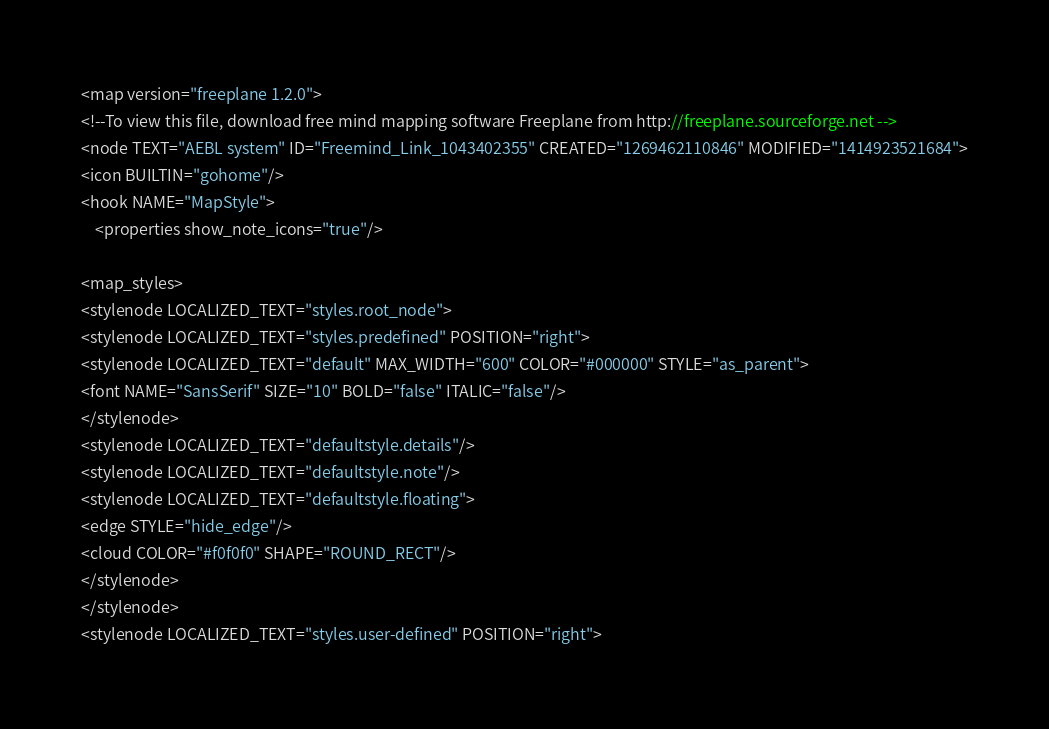Convert code to text. <code><loc_0><loc_0><loc_500><loc_500><_ObjectiveC_><map version="freeplane 1.2.0">
<!--To view this file, download free mind mapping software Freeplane from http://freeplane.sourceforge.net -->
<node TEXT="AEBL system" ID="Freemind_Link_1043402355" CREATED="1269462110846" MODIFIED="1414923521684">
<icon BUILTIN="gohome"/>
<hook NAME="MapStyle">
    <properties show_note_icons="true"/>

<map_styles>
<stylenode LOCALIZED_TEXT="styles.root_node">
<stylenode LOCALIZED_TEXT="styles.predefined" POSITION="right">
<stylenode LOCALIZED_TEXT="default" MAX_WIDTH="600" COLOR="#000000" STYLE="as_parent">
<font NAME="SansSerif" SIZE="10" BOLD="false" ITALIC="false"/>
</stylenode>
<stylenode LOCALIZED_TEXT="defaultstyle.details"/>
<stylenode LOCALIZED_TEXT="defaultstyle.note"/>
<stylenode LOCALIZED_TEXT="defaultstyle.floating">
<edge STYLE="hide_edge"/>
<cloud COLOR="#f0f0f0" SHAPE="ROUND_RECT"/>
</stylenode>
</stylenode>
<stylenode LOCALIZED_TEXT="styles.user-defined" POSITION="right"></code> 